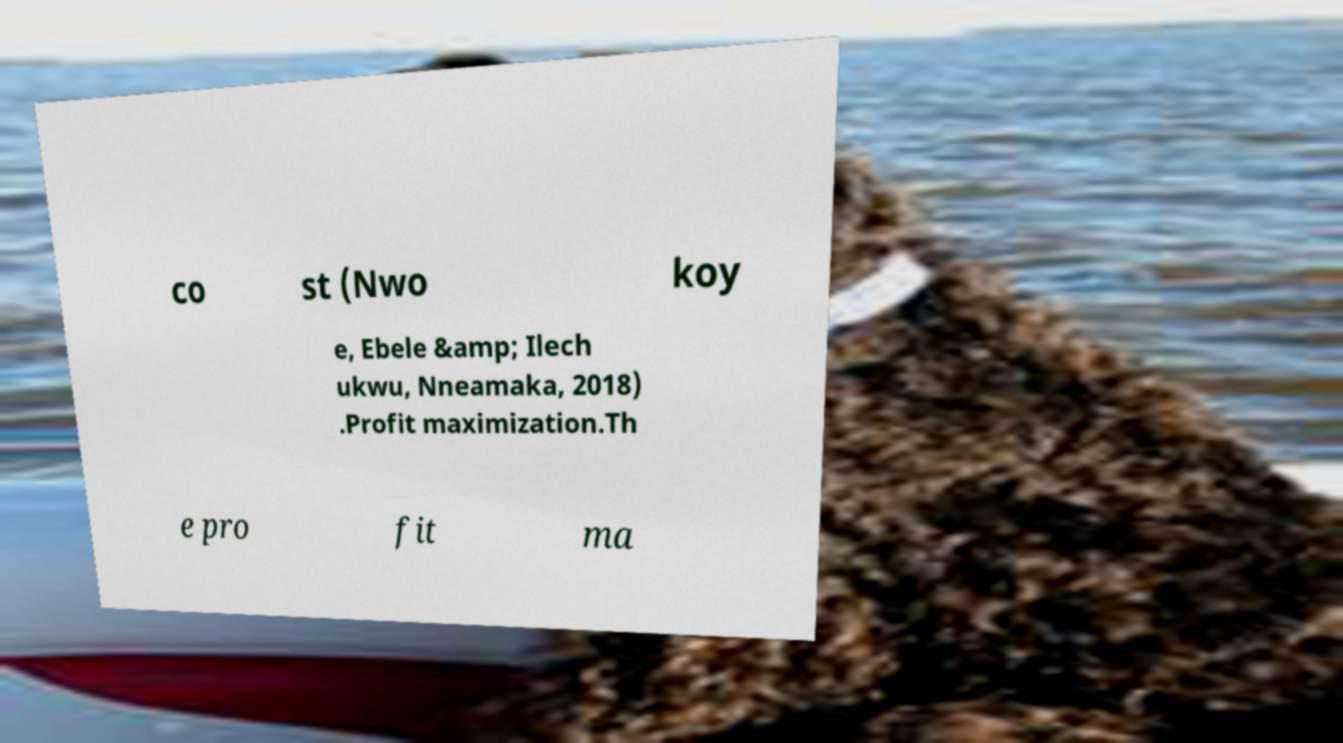Could you extract and type out the text from this image? co st (Nwo koy e, Ebele &amp; Ilech ukwu, Nneamaka, 2018) .Profit maximization.Th e pro fit ma 